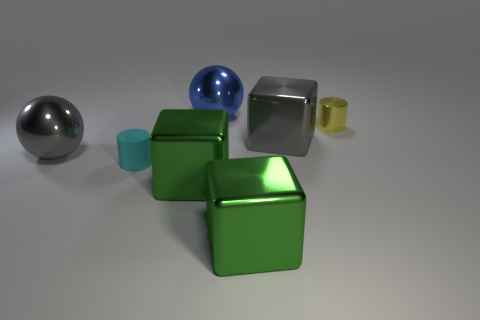Are there any other rubber things that have the same shape as the tiny rubber object?
Provide a short and direct response. No. There is a gray shiny thing in front of the gray shiny cube; is it the same size as the cylinder that is to the left of the large blue sphere?
Provide a short and direct response. No. Are there fewer cyan rubber things that are in front of the small rubber object than small cyan cylinders that are behind the blue sphere?
Your response must be concise. No. There is a shiny sphere that is in front of the large blue ball; what color is it?
Ensure brevity in your answer.  Gray. Do the matte cylinder and the metal cylinder have the same color?
Your answer should be compact. No. What number of small cyan cylinders are in front of the large gray shiny thing to the left of the small cyan matte cylinder that is to the left of the big blue metal sphere?
Offer a terse response. 1. What size is the gray metal block?
Your answer should be compact. Large. There is a cyan object that is the same size as the yellow metal thing; what is it made of?
Provide a short and direct response. Rubber. How many objects are in front of the small matte cylinder?
Provide a succinct answer. 2. Does the gray ball in front of the small yellow object have the same material as the ball that is to the right of the matte thing?
Your response must be concise. Yes. 